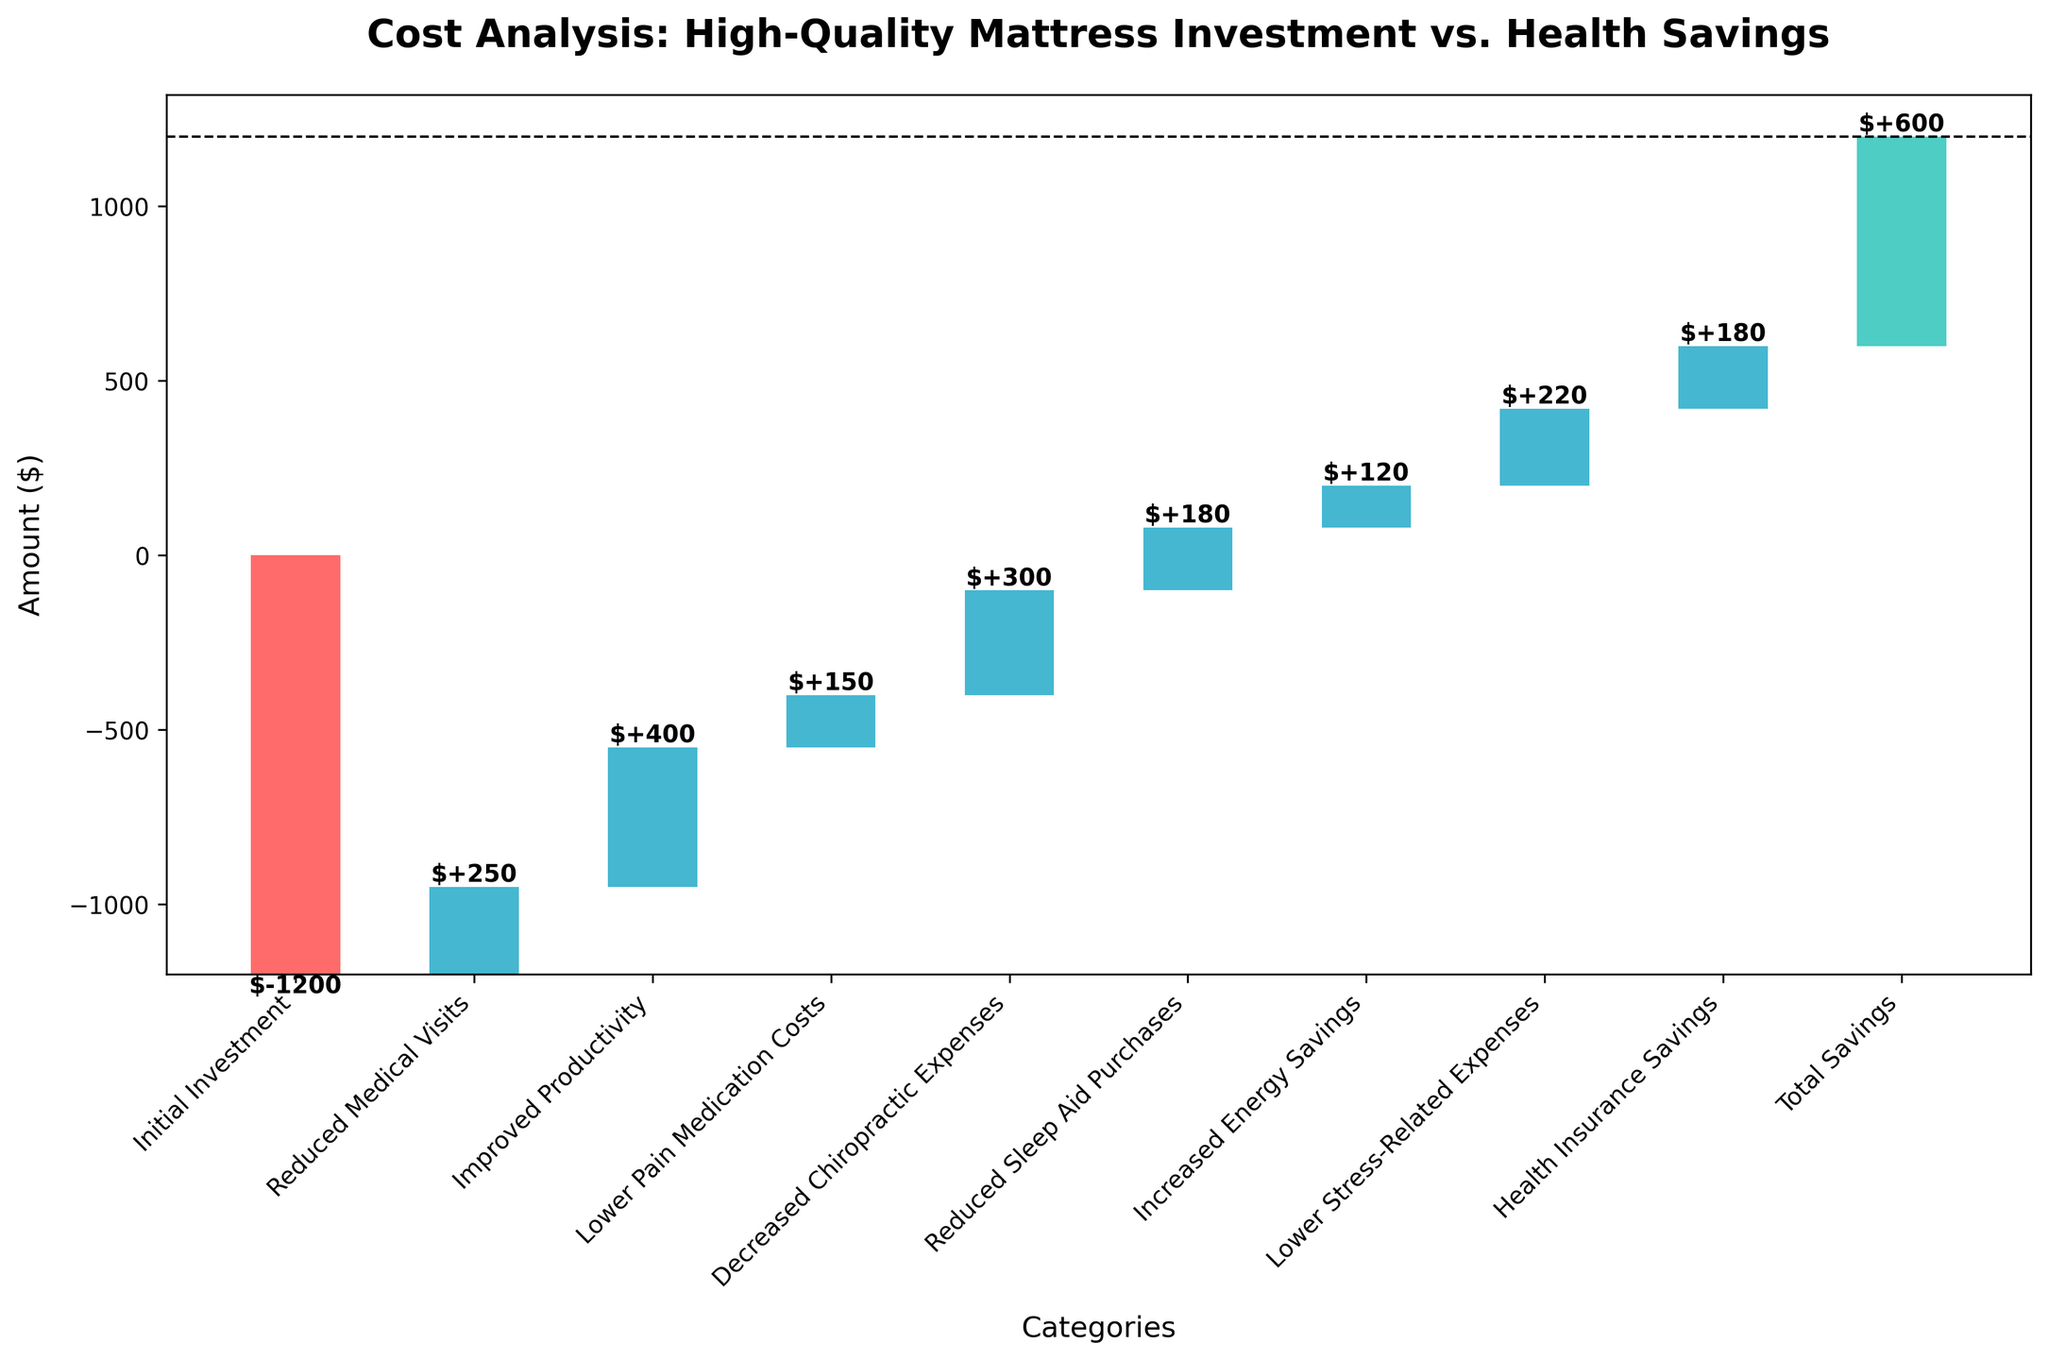What is the title of the chart? The title is usually displayed at the top of a chart and provides an overview of what the chart is about. Here, it can help identify the focus of the analysis.
Answer: Cost Analysis: High-Quality Mattress Investment vs. Health Savings How many categories are presented in the chart? By counting the number of bars in the chart, you can determine the number of categories presented. Here, each bar represents a category.
Answer: 10 What is the initial investment value? Look at the bar labeled "Initial Investment" and identify the corresponding value annotated on or near the bar.
Answer: -1200 Which category contributes the most to the savings from the high-quality mattress investment? Compare the magnitudes of the values of each category. The category with the highest positive value will be the one that contributes the most to savings.
Answer: Improved Productivity How much are the total savings from investing in the high-quality mattress? Find the bar labeled "Total Savings" and check the value annotated on or near the bar.
Answer: 600 What is the combined value of reduced medical visits, lower pain medication costs, and reduced sleep aid purchases? Add the values of these three categories together: 250 (Reduced Medical Visits) + 150 (Lower Pain Medication Costs) + 180 (Reduced Sleep Aid Purchases).
Answer: 580 Which provides a larger savings: decreased chiropractic expenses or health insurance savings? Compare the values of these two categories by checking their respective bars and annotations.
Answer: Decreased Chiropractic Expenses How does the color scheme differentiate between the initial investment, intermediate savings, and total savings? Observe the colors used for the different bars. Initial investment and intermediate savings usually have different colors, and total savings might differ as well. Explain the significance.
Answer: Initial investment bars are red, intermediate savings bars are blue, and total savings bar is green What is the increase in energy savings from the high-quality mattress? Look at the bar labeled "Increased Energy Savings" and identify the corresponding value annotated on or near the bar.
Answer: 120 How does the value of decreased chiropractic expenses compare to reduced sleep aid purchases? Compare the values of these two categories by checking their respective bars and annotations.
Answer: Decreased Chiropractic Expenses is higher (300 vs. 180) 